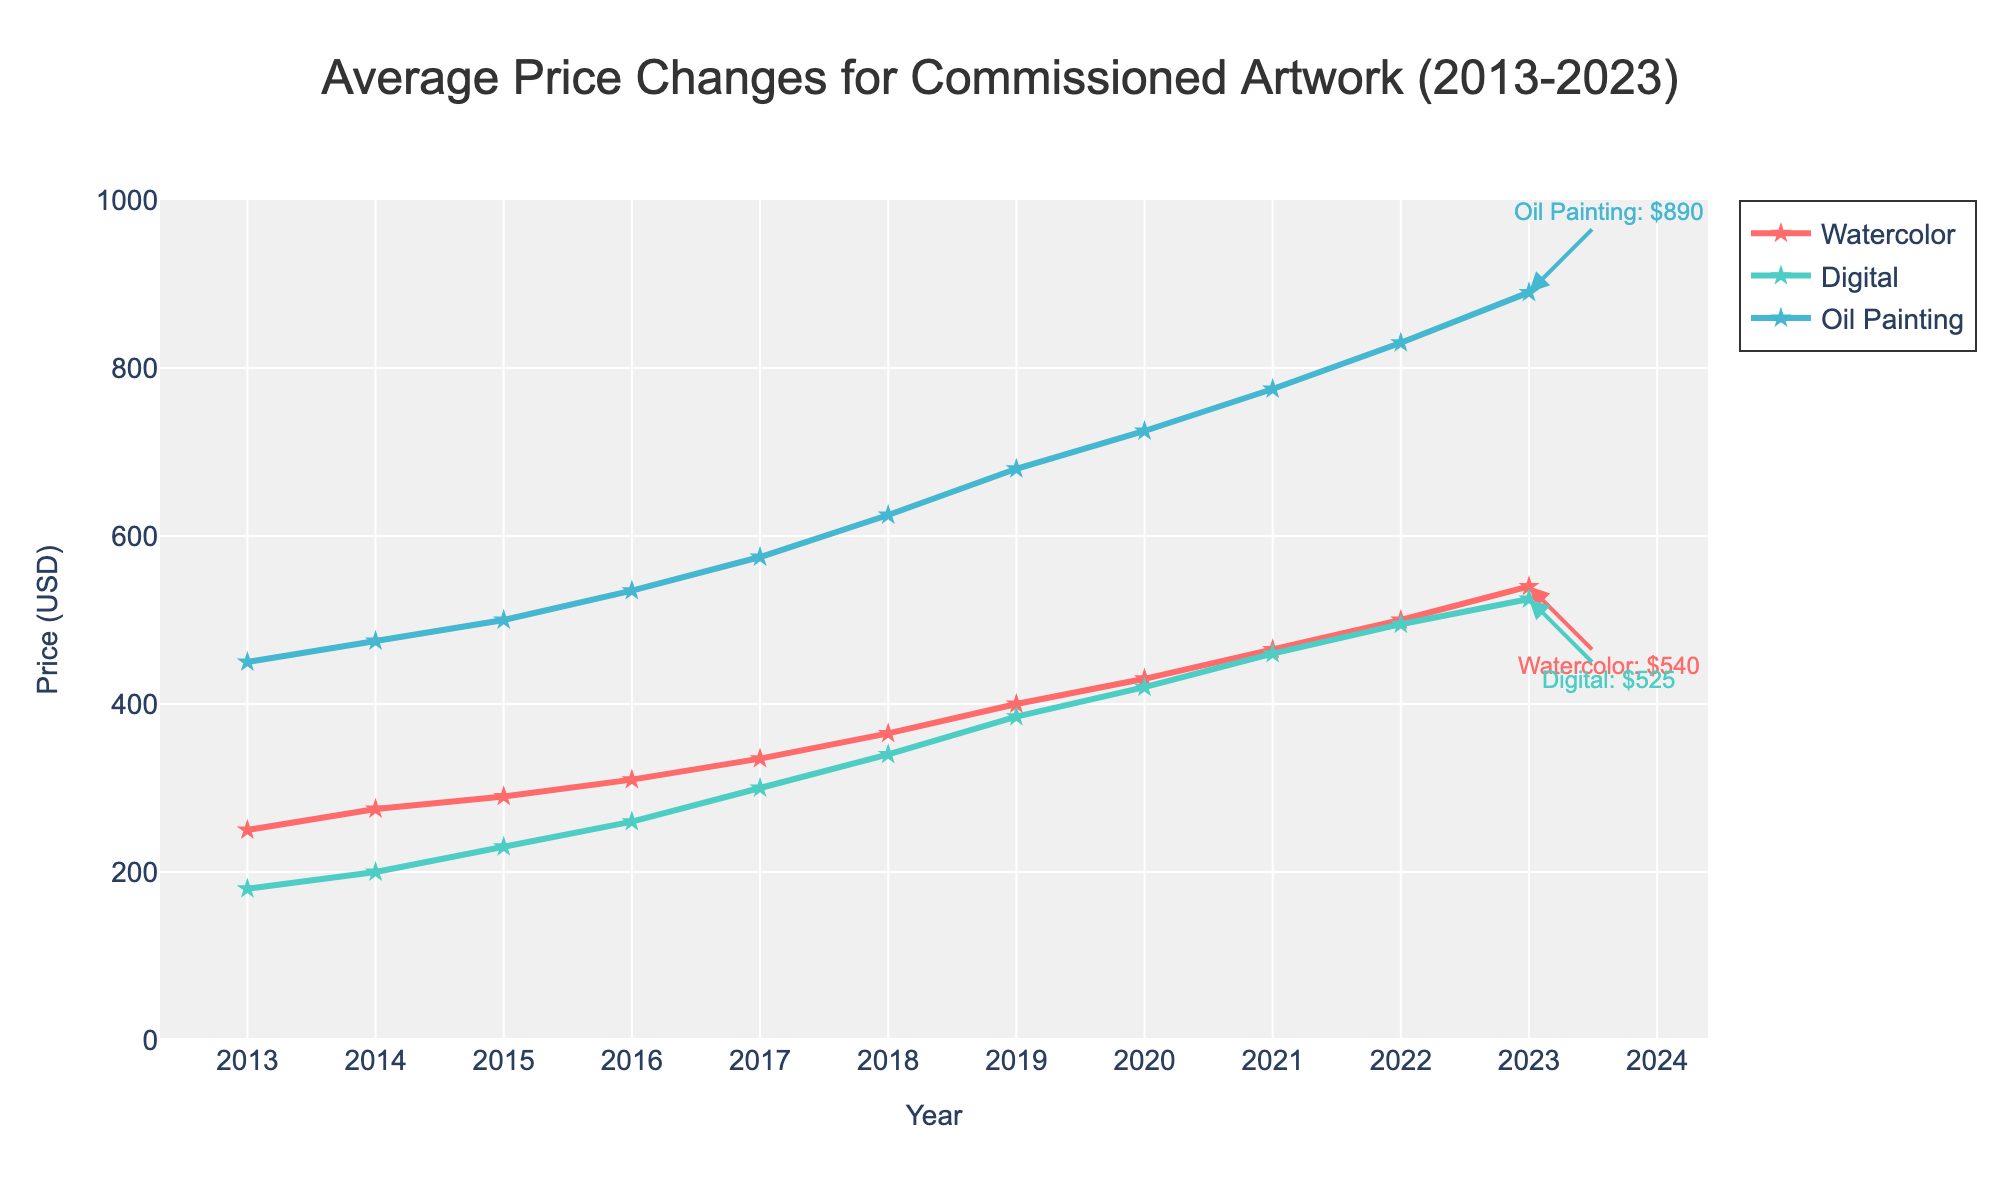What has been the overall trend in the price of watercolor artwork from 2013 to 2023? By examining the line for watercolor, we see it starts at $250 in 2013 and increases steadily each year, reaching $540 in 2023. The consistent upward movement demonstrates an increasing trend.
Answer: Prices for watercolor artwork have been consistently rising from 2013 to 2023 Which medium had the highest price increase from 2013 to 2023? To determine this, we subtract the prices in 2013 from the prices in 2023 for all three mediums:
Watercolor: 540 - 250 = 290
Digital: 525 - 180 = 345
Oil Painting: 890 - 450 = 440
The Oil Painting price had the highest increase at $440.
Answer: Oil Painting In 2017, which medium had the highest average price, and what was it? Look at the 2017 data points and compare the prices:
Watercolor: $335
Digital: $300
Oil Painting: $575
Oil Painting had the highest average price at $575.
Answer: Oil Painting: $575 During which period did digital artwork see the most significant price increase? To find this, compare the year-to-year increments for digital artwork:
2013-2014: 200-180 = 20
2014-2015: 230-200 = 30
2015-2016: 260-230 = 30
2016-2017: 300-260 = 40
2017-2018: 340-300 = 40
2018-2019: 385-340 = 45
2019-2020: 420-385 = 35
2020-2021: 460-420 = 40
2021-2022: 495-460 = 35
2022-2023: 525-495 = 30
The most significant price increase for digital artwork was between 2018 and 2019 at $45.
Answer: 2018-2019 Compare the price of oil paintings and digital artwork in 2023. Which one is higher and by how much? In 2023, the price for oil paintings is $890 and for digital artwork is $525. 
Calculate the difference: 890 - 525 = 365
Oil paintings are higher by $365.
Answer: Oil Painting by $365 What is the average price of watercolor artwork between 2013 and 2023? Sum the prices of watercolor artwork from 2013 to 2023: 
250 + 275 + 290 + 310 + 335 + 365 + 400 + 430 + 465 + 500 + 540 = 4160
Then divide by the number of years: 4160 / 11 = 378.18
The average price of watercolor artwork over this period is approximately $378.18.
Answer: $378.18 What color is used to represent digital artwork in the plot? The question asks about the visual attribute regarding color. The line representing Digital artwork is depicted in green.
Answer: Green 